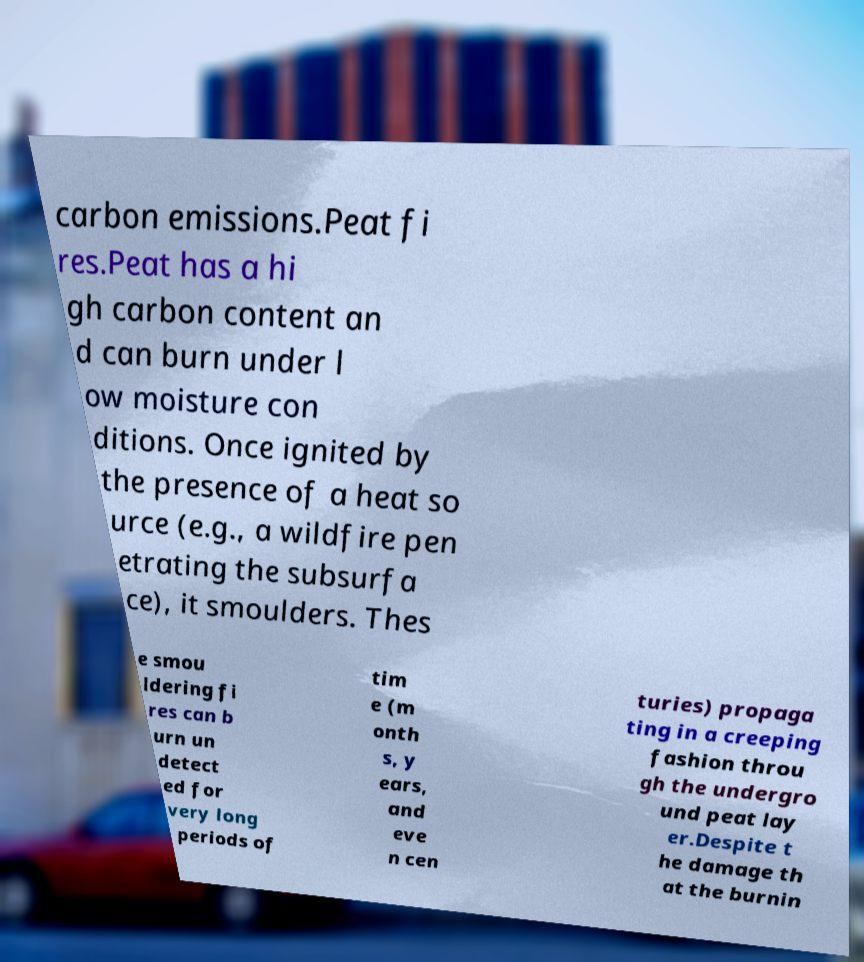There's text embedded in this image that I need extracted. Can you transcribe it verbatim? carbon emissions.Peat fi res.Peat has a hi gh carbon content an d can burn under l ow moisture con ditions. Once ignited by the presence of a heat so urce (e.g., a wildfire pen etrating the subsurfa ce), it smoulders. Thes e smou ldering fi res can b urn un detect ed for very long periods of tim e (m onth s, y ears, and eve n cen turies) propaga ting in a creeping fashion throu gh the undergro und peat lay er.Despite t he damage th at the burnin 